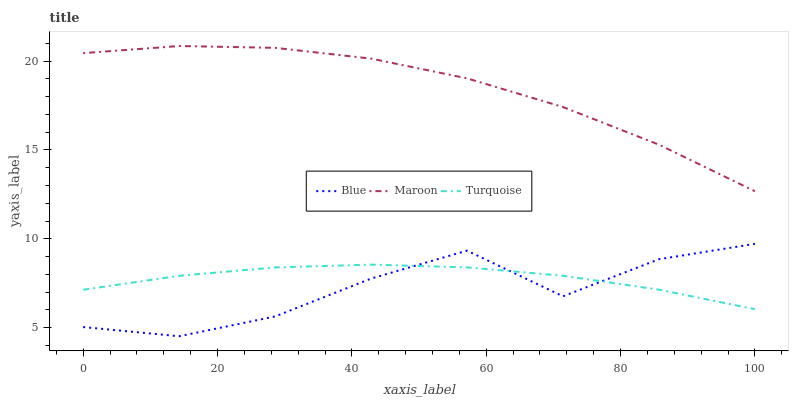Does Blue have the minimum area under the curve?
Answer yes or no. Yes. Does Maroon have the maximum area under the curve?
Answer yes or no. Yes. Does Turquoise have the minimum area under the curve?
Answer yes or no. No. Does Turquoise have the maximum area under the curve?
Answer yes or no. No. Is Turquoise the smoothest?
Answer yes or no. Yes. Is Blue the roughest?
Answer yes or no. Yes. Is Maroon the smoothest?
Answer yes or no. No. Is Maroon the roughest?
Answer yes or no. No. Does Blue have the lowest value?
Answer yes or no. Yes. Does Turquoise have the lowest value?
Answer yes or no. No. Does Maroon have the highest value?
Answer yes or no. Yes. Does Turquoise have the highest value?
Answer yes or no. No. Is Blue less than Maroon?
Answer yes or no. Yes. Is Maroon greater than Blue?
Answer yes or no. Yes. Does Blue intersect Turquoise?
Answer yes or no. Yes. Is Blue less than Turquoise?
Answer yes or no. No. Is Blue greater than Turquoise?
Answer yes or no. No. Does Blue intersect Maroon?
Answer yes or no. No. 